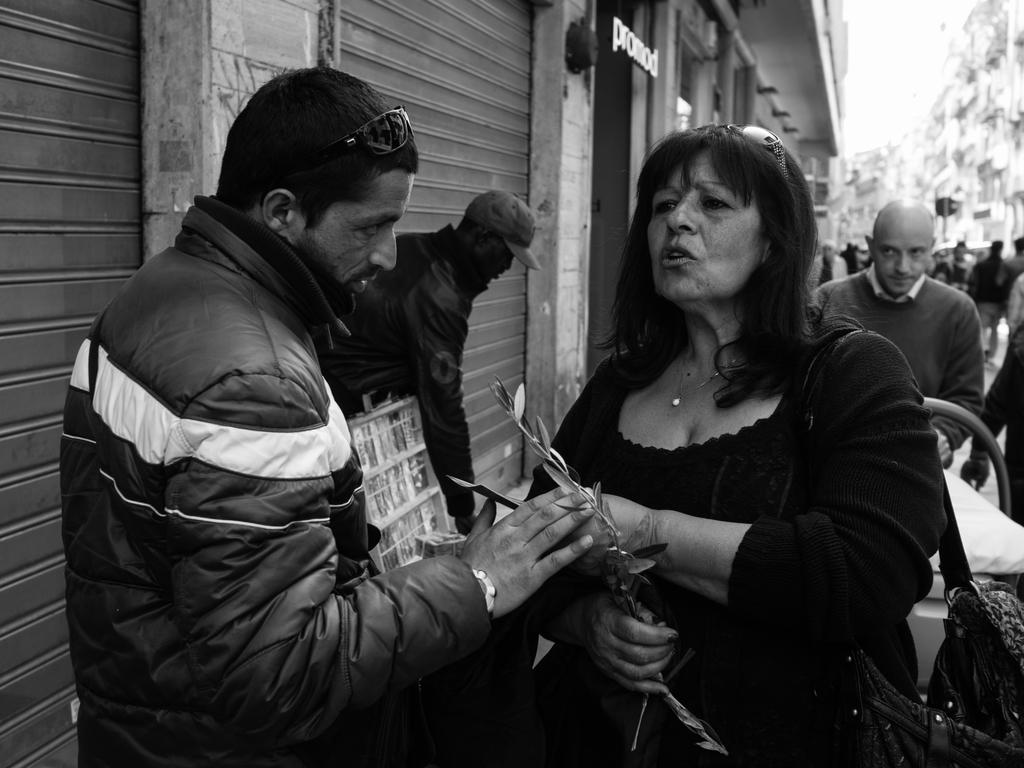What type of shutters are visible in the image? There are rolling shutters in the image. Who or what else can be seen in the image? There are people and buildings in the image. What type of prose is being recited by the snake in the image? There is no snake or prose present in the image. 